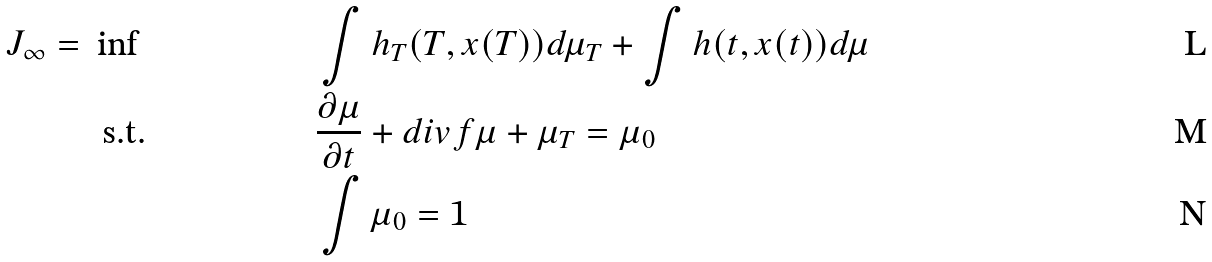<formula> <loc_0><loc_0><loc_500><loc_500>J _ { \infty } = \ & \inf & & \int h _ { T } ( T , x ( T ) ) d \mu _ { T } + \int h ( t , x ( t ) ) d \mu & \\ & \ \text {s.t.} & & \frac { \partial \mu } { \partial t } + d i v f \mu + \mu _ { T } = \mu _ { 0 } & \\ & & & \int \mu _ { 0 } = 1</formula> 